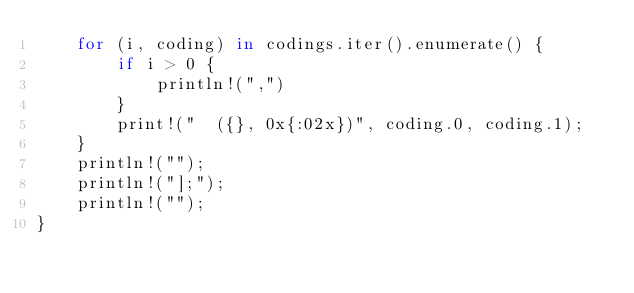Convert code to text. <code><loc_0><loc_0><loc_500><loc_500><_Rust_>    for (i, coding) in codings.iter().enumerate() {
        if i > 0 {
            println!(",")
        }
        print!("  ({}, 0x{:02x})", coding.0, coding.1);
    }
    println!("");
    println!("];");
    println!("");
}
</code> 